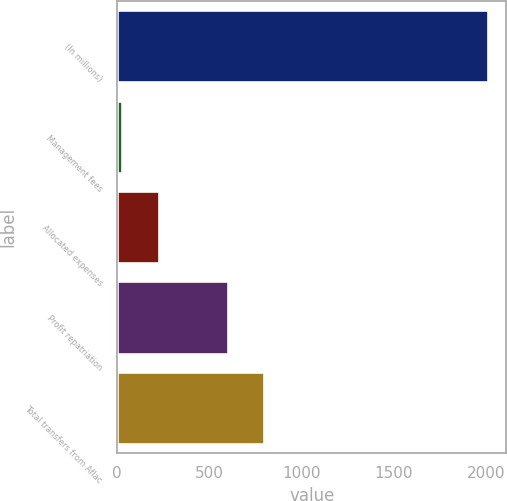Convert chart. <chart><loc_0><loc_0><loc_500><loc_500><bar_chart><fcel>(In millions)<fcel>Management fees<fcel>Allocated expenses<fcel>Profit repatriation<fcel>Total transfers from Aflac<nl><fcel>2008<fcel>26<fcel>224.2<fcel>598<fcel>796.2<nl></chart> 